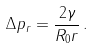<formula> <loc_0><loc_0><loc_500><loc_500>\Delta p _ { r } = \frac { 2 \gamma } { R _ { 0 } r } \, .</formula> 